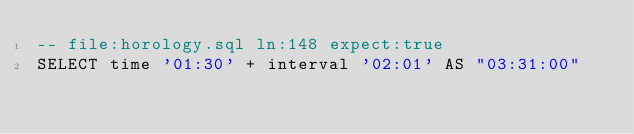<code> <loc_0><loc_0><loc_500><loc_500><_SQL_>-- file:horology.sql ln:148 expect:true
SELECT time '01:30' + interval '02:01' AS "03:31:00"
</code> 